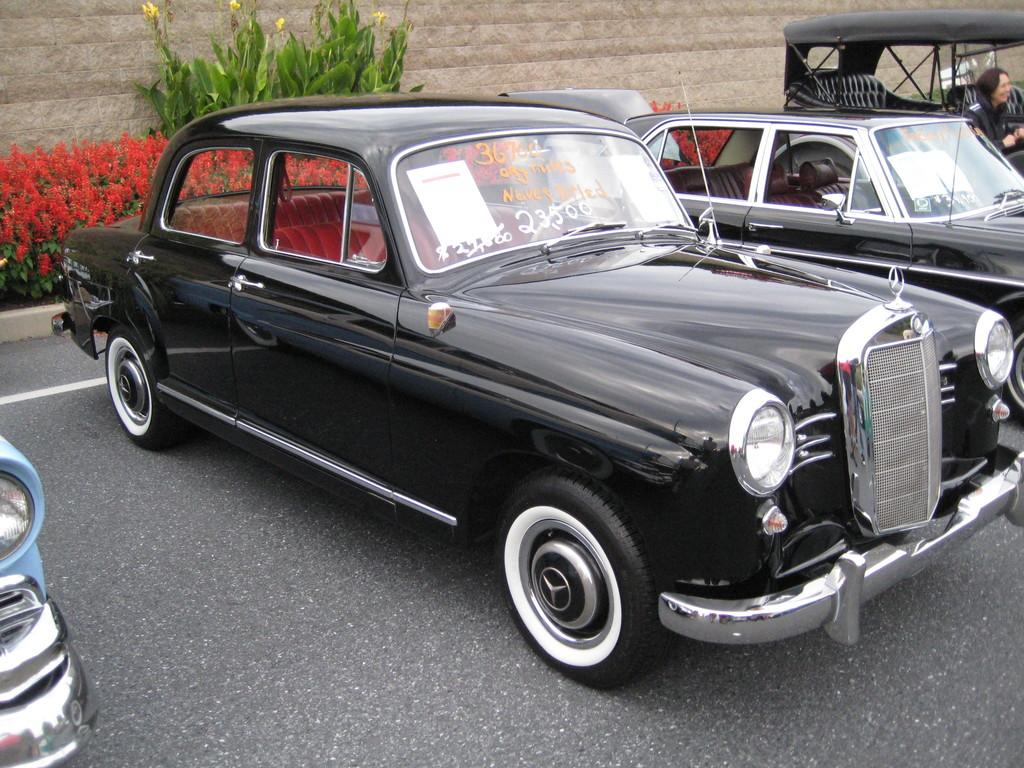What types of vehicles can be seen in the image? There are vehicles of different colors and sizes in the image. Can you describe the person in the image? There is a person sitting in one of the vehicles, and they are wearing clothes. What is the setting of the image? There is a road visible in the image, along with flower plants and a wall. Where is the jar located in the image? There is no jar present in the image. Can you describe the tent in the image? There is no tent present in the image. 